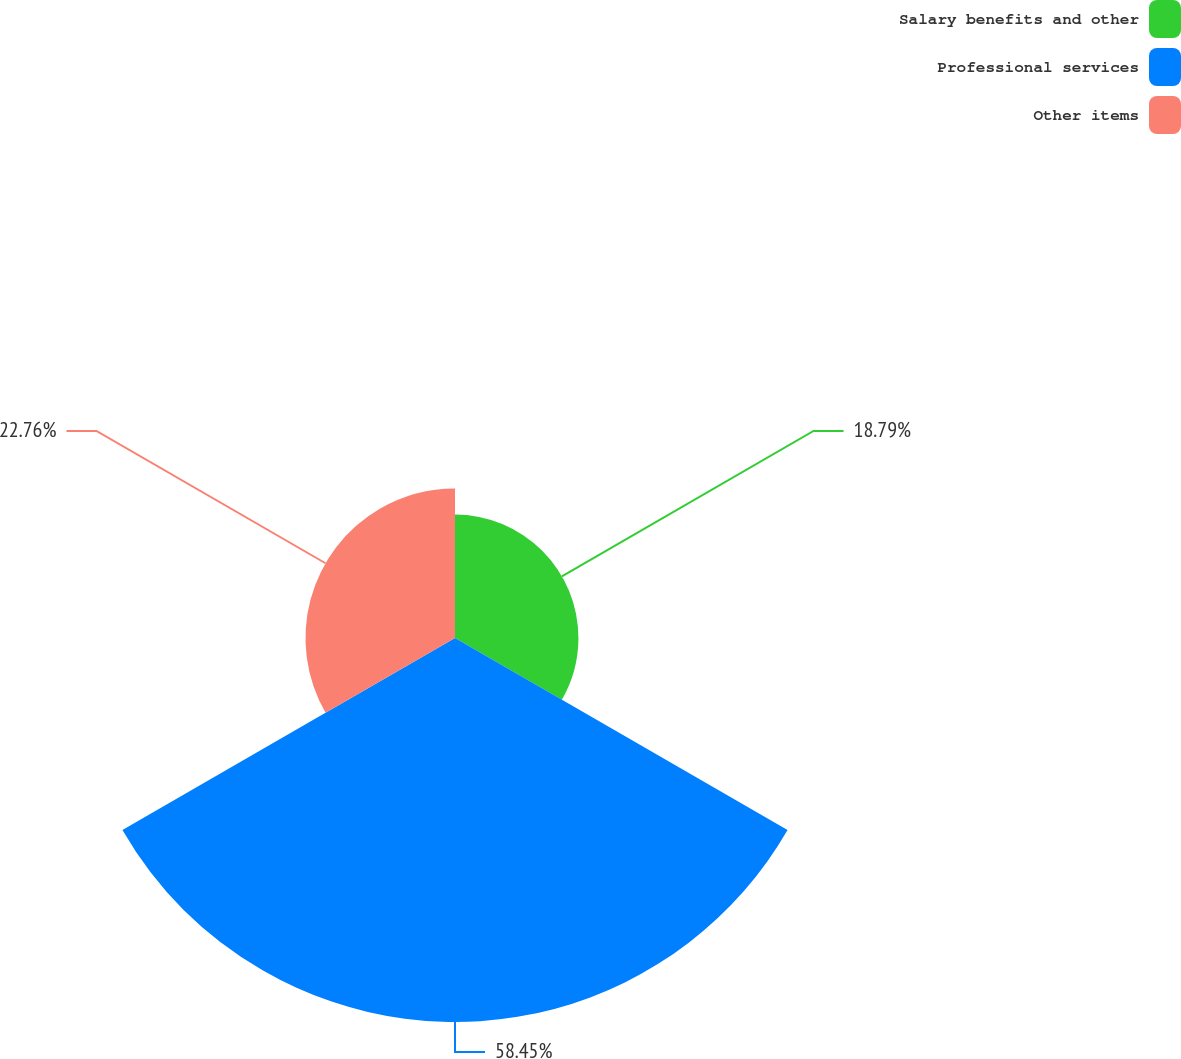<chart> <loc_0><loc_0><loc_500><loc_500><pie_chart><fcel>Salary benefits and other<fcel>Professional services<fcel>Other items<nl><fcel>18.79%<fcel>58.46%<fcel>22.76%<nl></chart> 